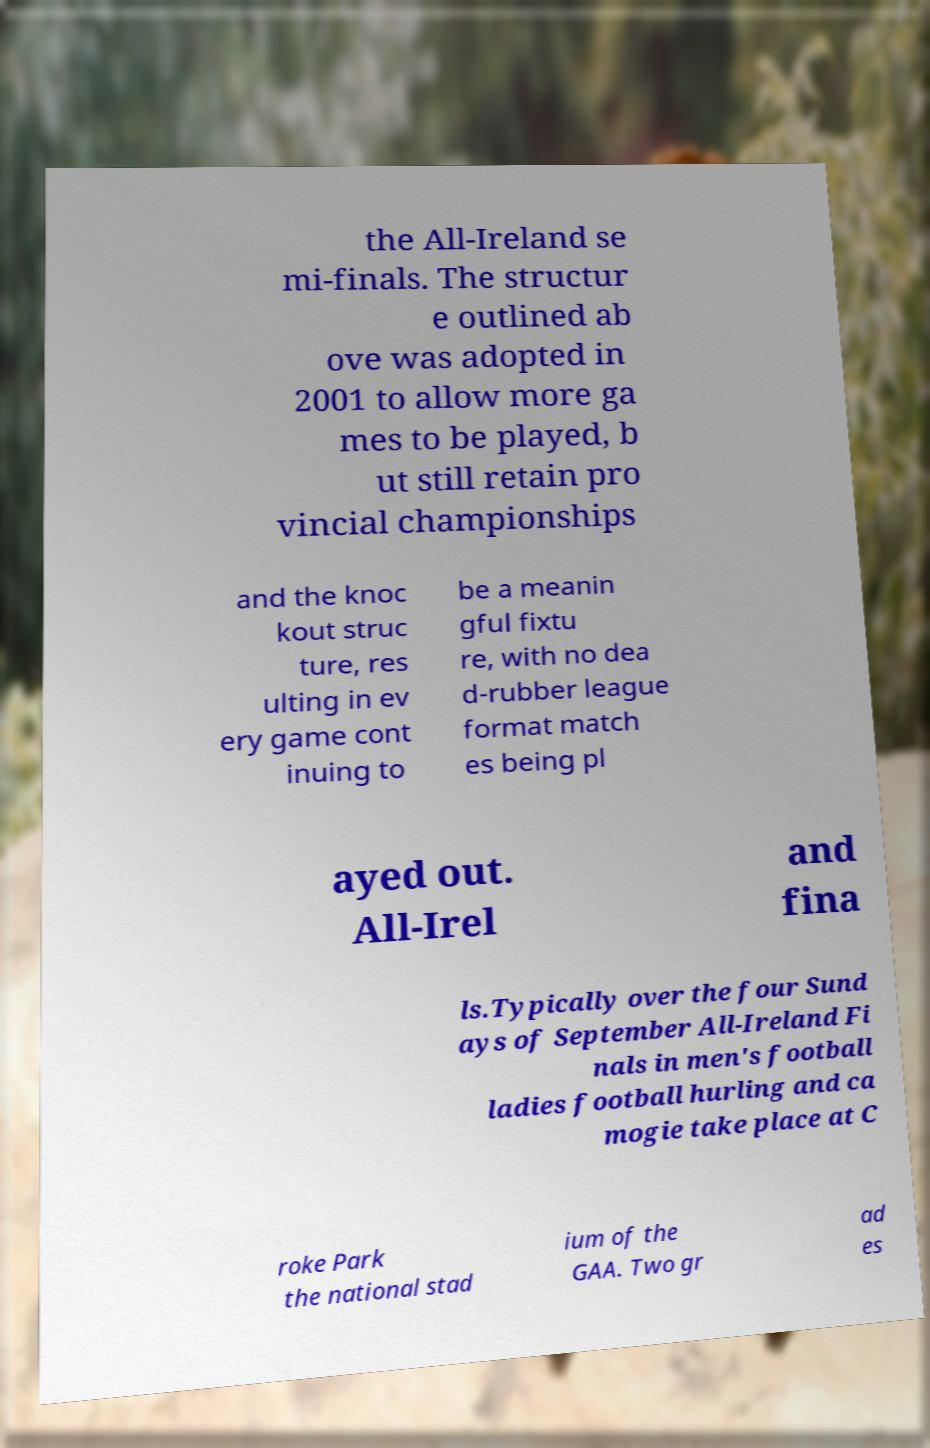For documentation purposes, I need the text within this image transcribed. Could you provide that? the All-Ireland se mi-finals. The structur e outlined ab ove was adopted in 2001 to allow more ga mes to be played, b ut still retain pro vincial championships and the knoc kout struc ture, res ulting in ev ery game cont inuing to be a meanin gful fixtu re, with no dea d-rubber league format match es being pl ayed out. All-Irel and fina ls.Typically over the four Sund ays of September All-Ireland Fi nals in men's football ladies football hurling and ca mogie take place at C roke Park the national stad ium of the GAA. Two gr ad es 